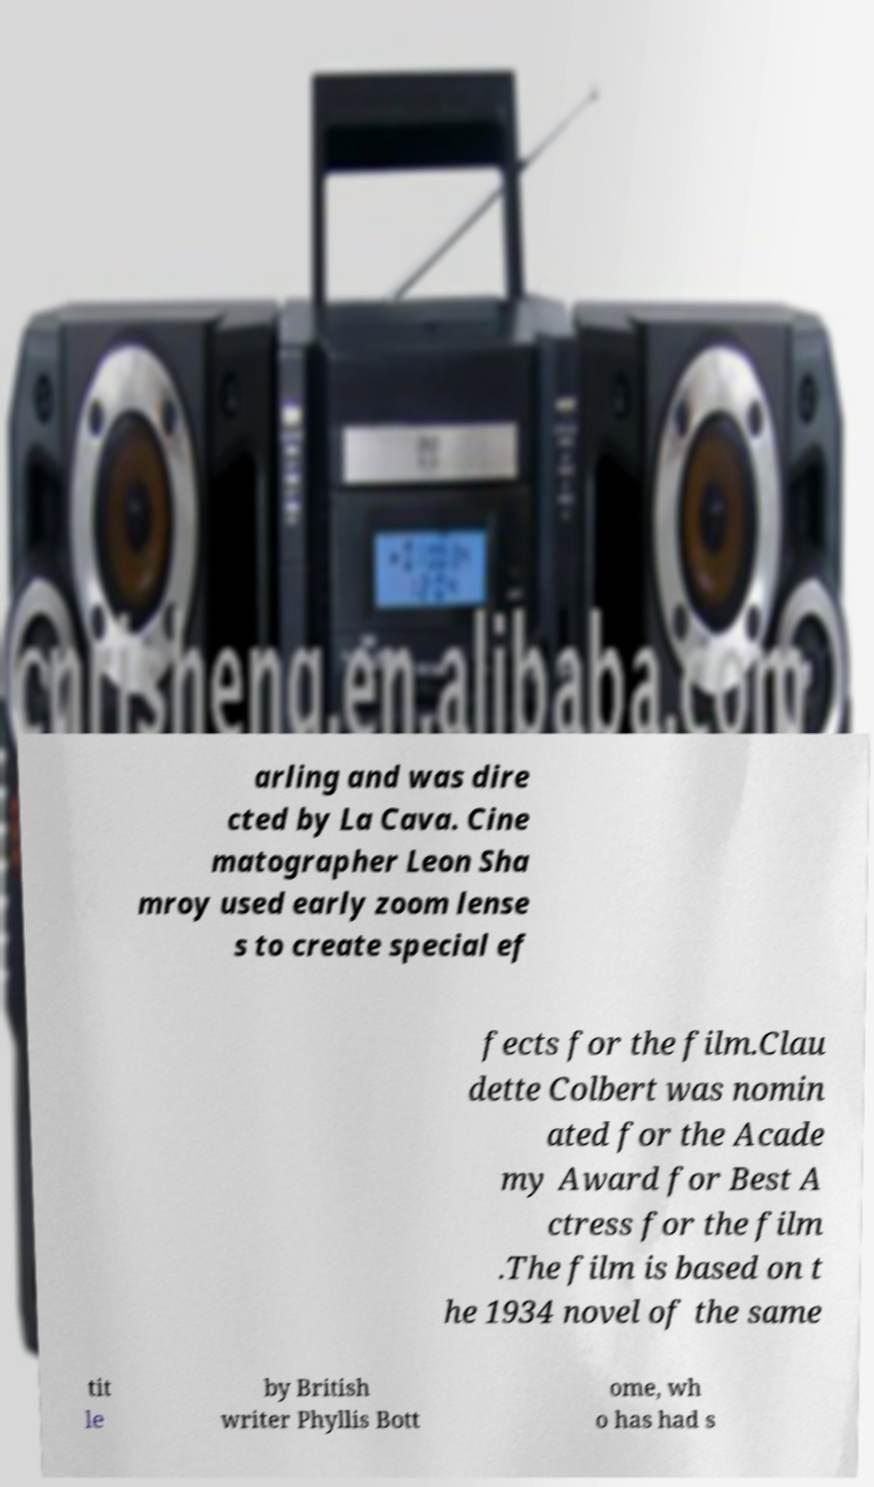Could you extract and type out the text from this image? arling and was dire cted by La Cava. Cine matographer Leon Sha mroy used early zoom lense s to create special ef fects for the film.Clau dette Colbert was nomin ated for the Acade my Award for Best A ctress for the film .The film is based on t he 1934 novel of the same tit le by British writer Phyllis Bott ome, wh o has had s 